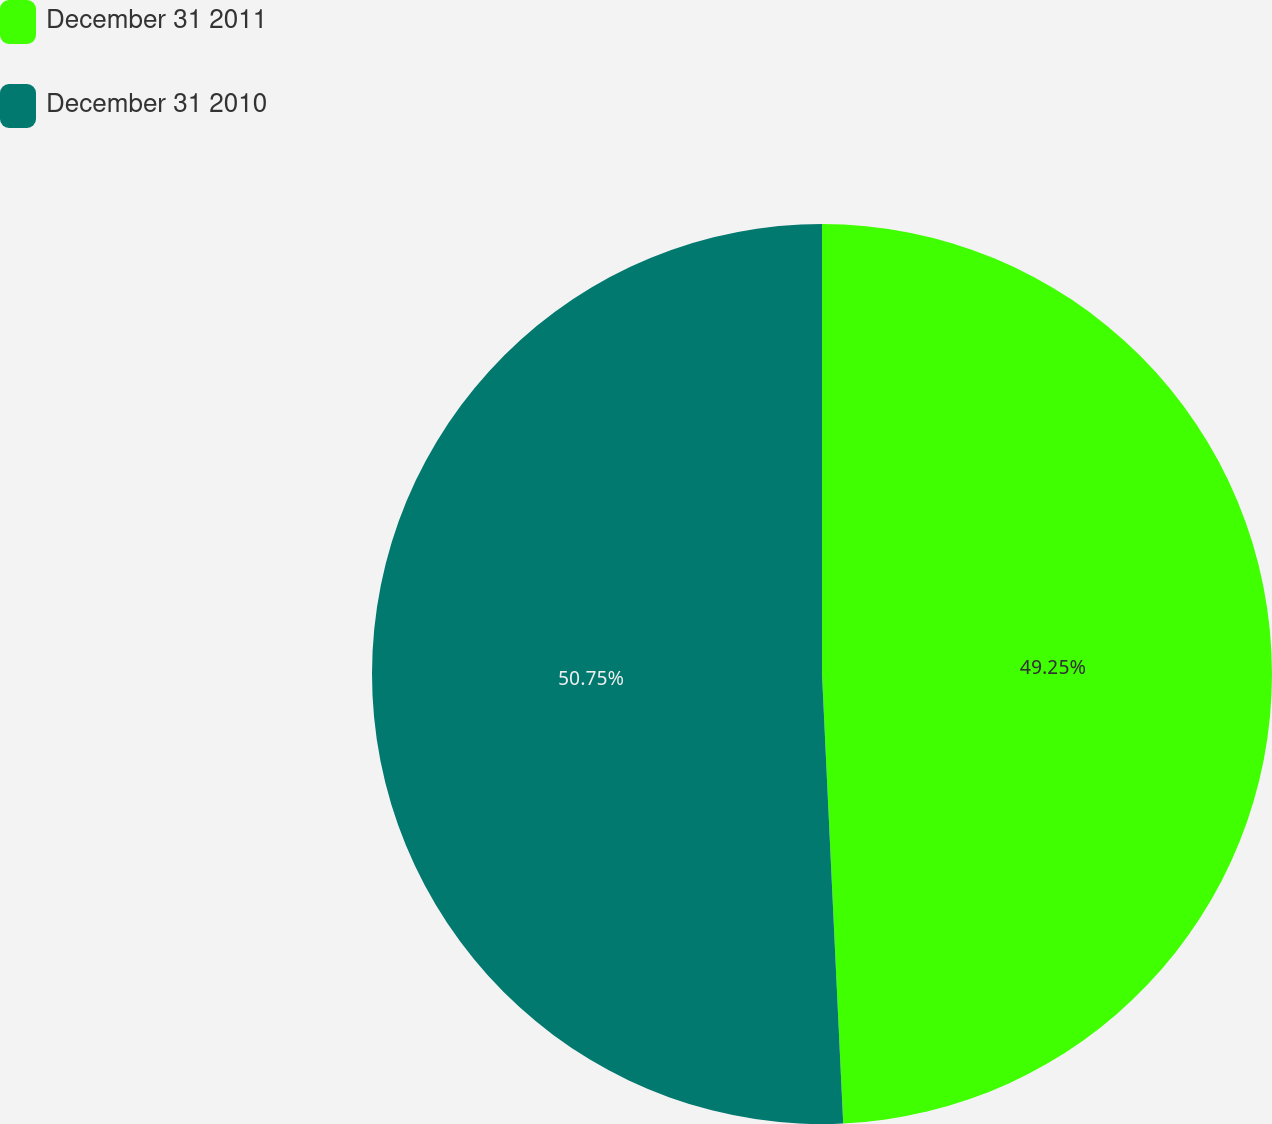<chart> <loc_0><loc_0><loc_500><loc_500><pie_chart><fcel>December 31 2011<fcel>December 31 2010<nl><fcel>49.25%<fcel>50.75%<nl></chart> 